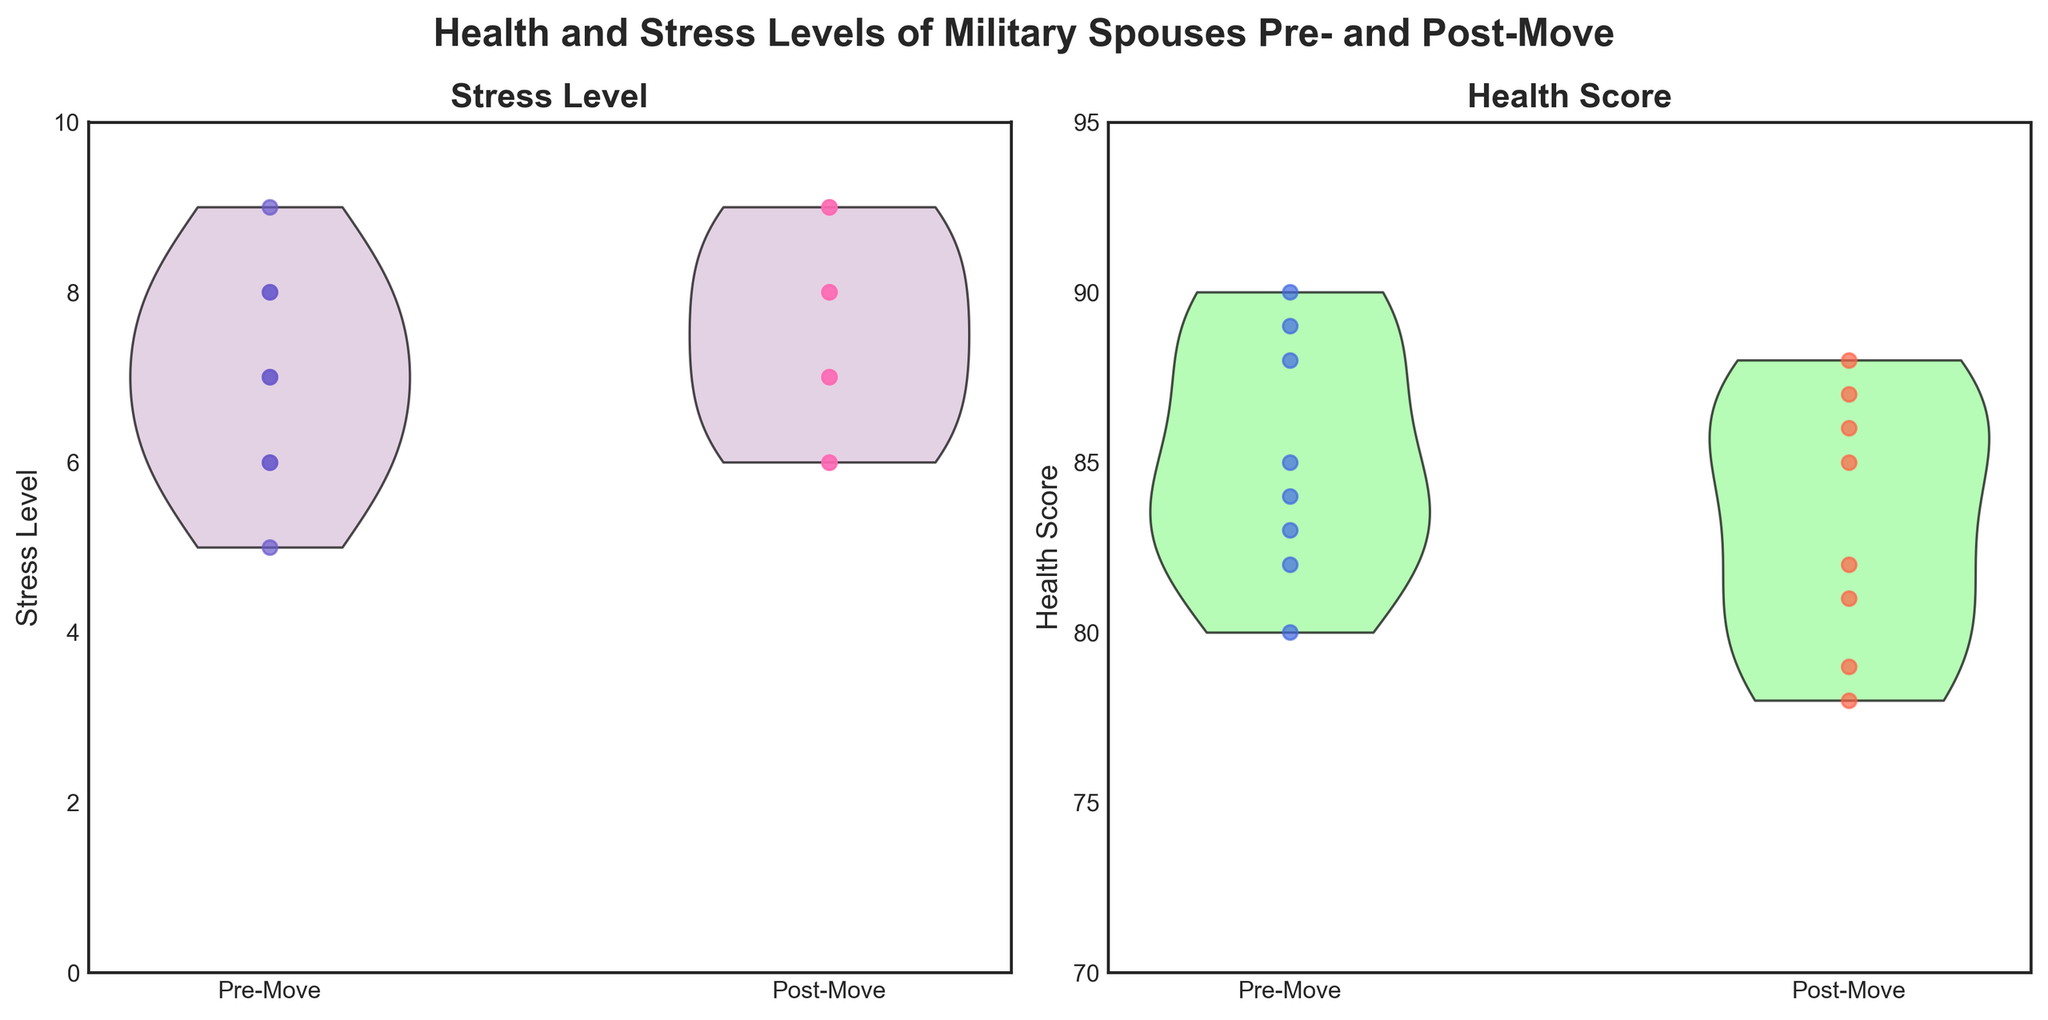How many data points are there for both pre-move and post-move stress levels? There are 8 data points each for pre-move and post-move stress levels, as the scatterplots in the Stress Level violin plot show 8 dots for pre-move and 8 dots for post-move.
Answer: 8 Which group, pre-move or post-move, has a higher peak density of stress levels? By examining the wider part of the violins in the Stress Level plot, we can see that the post-move group has the larger and broader peak, indicating a higher peak density of stress levels compared to the pre-move group.
Answer: Post-move What is the range of health scores for both pre-move and post-move? The health score violin plot indicates the range of health scores for pre-move (from approximately 80 to 90) and post-move (from around 78 to 88).
Answer: Pre: ~80-90, Post: ~78-88 Compare the median stress levels for pre-move and post-move groups. Although exact median values aren't shown directly on the plot, the scatterplots suggest that the median stress level for the pre-move group should be around 7 (as the distribution is centered around 6-7), while for the post-move group it's around 8.
Answer: Pre: ~7, Post: ~8 In the post-move group, which metric shows a larger spread: stress levels or health scores? In the post-move group, the health scores have a spread ranging from 78 to 88 (a range of 10), whereas stress levels range from 6 to 9 (a range of 3), indicating that health scores have a larger spread.
Answer: Health scores Is the average stress level higher in the pre-move group or the post-move group? The post-move group has an average stress level around 8, while the pre-move group averages around 7, as indicated by the distribution of data points and the density of the violin plots. Therefore, post-move has a higher average stress level.
Answer: Post-move Which group has more variability in health scores, pre-move or post-move? The violin plot for health scores shows a wider distribution for the post-move group compared to the pre-move group, implying more variability in the post-move health scores.
Answer: Post-move What color represents the stress level scatter data points for pre-move and post-move? The scatter data points for the pre-move stress levels are colored in a shade of blue (which appears purple as mixed with violin plot), and the post-move stress levels are pink.
Answer: Pre-move: blue-ish, Post-move: pink Which group—pre-move or post-move—has a higher concentration of low health scores? The post-move violin plot for health scores bulges more near the lower end (around 78), indicating a higher concentration of low health scores compared to the pre-move group, which is more centered and higher.
Answer: Post-move Are there more pre-move or post-move spouses with a health score above 85? By counting the scatter points above 85 in the health score plot, there are more pre-move scatter points above 85 compared to post-move.
Answer: Pre-move 